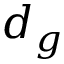Convert formula to latex. <formula><loc_0><loc_0><loc_500><loc_500>d _ { g }</formula> 